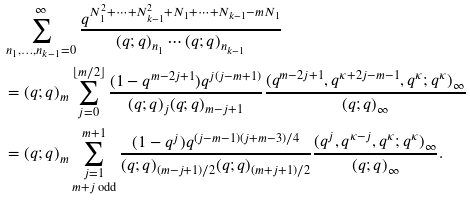<formula> <loc_0><loc_0><loc_500><loc_500>& \sum _ { n _ { 1 } , \dots , n _ { k - 1 } = 0 } ^ { \infty } \frac { q ^ { N _ { 1 } ^ { 2 } + \cdots + N _ { k - 1 } ^ { 2 } + N _ { 1 } + \cdots + N _ { k - 1 } - m N _ { 1 } } } { ( q ; q ) _ { n _ { 1 } } \cdots ( q ; q ) _ { n _ { k - 1 } } } \\ & = ( q ; q ) _ { m } \sum _ { j = 0 } ^ { \lfloor m / 2 \rfloor } \frac { ( 1 - q ^ { m - 2 j + 1 } ) q ^ { j ( j - m + 1 ) } } { ( q ; q ) _ { j } ( q ; q ) _ { m - j + 1 } } \frac { ( q ^ { m - 2 j + 1 } , q ^ { \kappa + 2 j - m - 1 } , q ^ { \kappa } ; q ^ { \kappa } ) _ { \infty } } { ( q ; q ) _ { \infty } } \\ & = ( q ; q ) _ { m } \sum _ { \substack { j = 1 \\ m + j \text { odd} } } ^ { m + 1 } \frac { ( 1 - q ^ { j } ) q ^ { ( j - m - 1 ) ( j + m - 3 ) / 4 } } { ( q ; q ) _ { ( m - j + 1 ) / 2 } ( q ; q ) _ { ( m + j + 1 ) / 2 } } \frac { ( q ^ { j } , q ^ { \kappa - j } , q ^ { \kappa } ; q ^ { \kappa } ) _ { \infty } } { ( q ; q ) _ { \infty } } .</formula> 